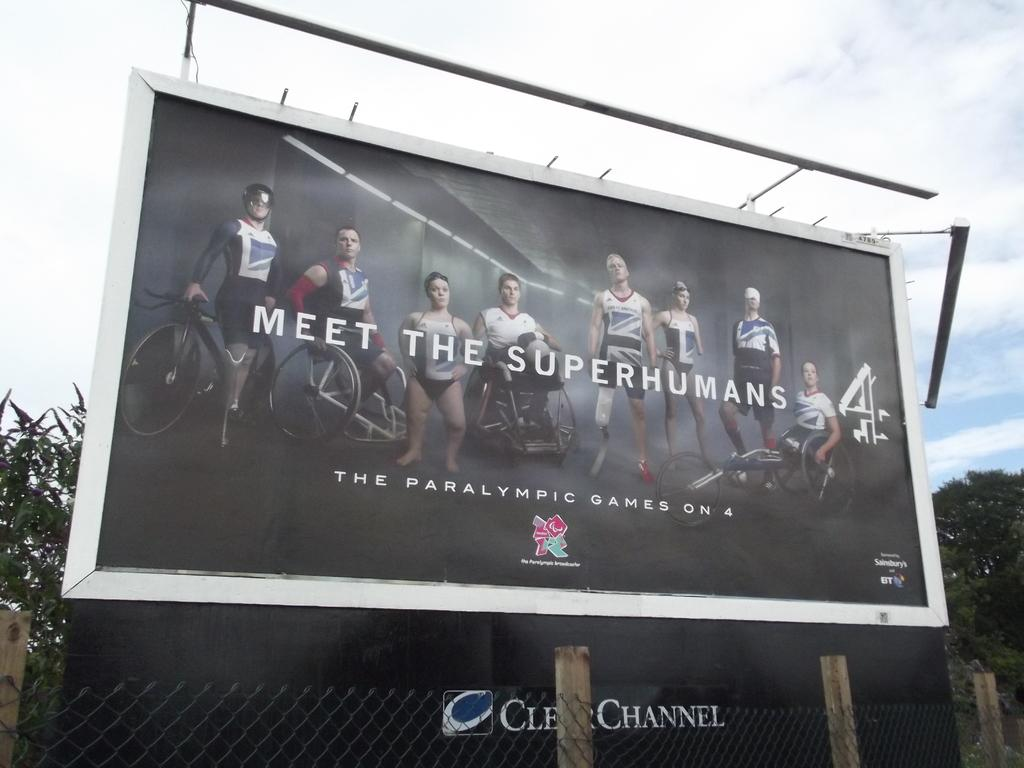<image>
Share a concise interpretation of the image provided. A billboard sign that says Meet The Superhumans 